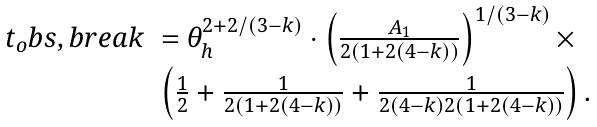Convert formula to latex. <formula><loc_0><loc_0><loc_500><loc_500>\begin{array} { r l } t _ { o } b s , b r e a k & = \theta _ { h } ^ { 2 + 2 / ( 3 - k ) } \cdot \left ( \frac { A _ { 1 } } { 2 ( 1 + 2 ( 4 - k ) ) } \right ) ^ { 1 / ( 3 - k ) } \times \\ & \left ( \frac { 1 } { 2 } + \frac { 1 } { 2 ( 1 + 2 ( 4 - k ) ) } + \frac { 1 } { 2 ( 4 - k ) 2 ( 1 + 2 ( 4 - k ) ) } \right ) . \end{array}</formula> 